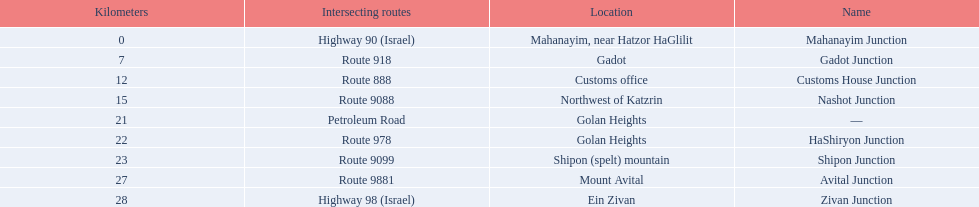What are all of the junction names? Mahanayim Junction, Gadot Junction, Customs House Junction, Nashot Junction, —, HaShiryon Junction, Shipon Junction, Avital Junction, Zivan Junction. What are their locations in kilometers? 0, 7, 12, 15, 21, 22, 23, 27, 28. Between shipon and avital, whicih is nashot closer to? Shipon Junction. 